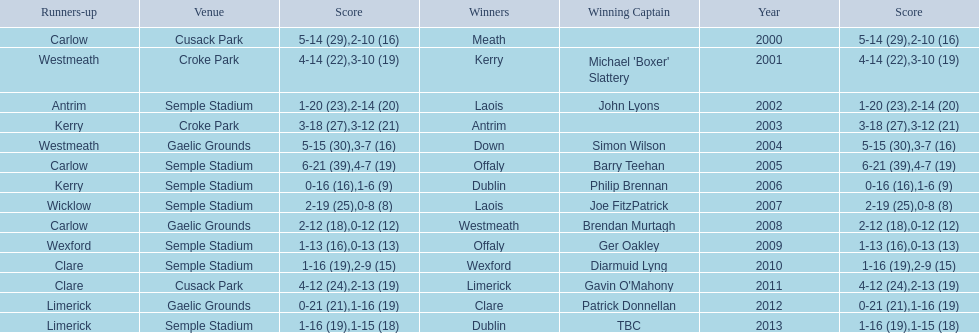What is the difference in the scores in 2000? 13. 